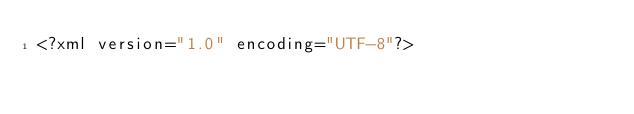<code> <loc_0><loc_0><loc_500><loc_500><_HTML_><?xml version="1.0" encoding="UTF-8"?></code> 